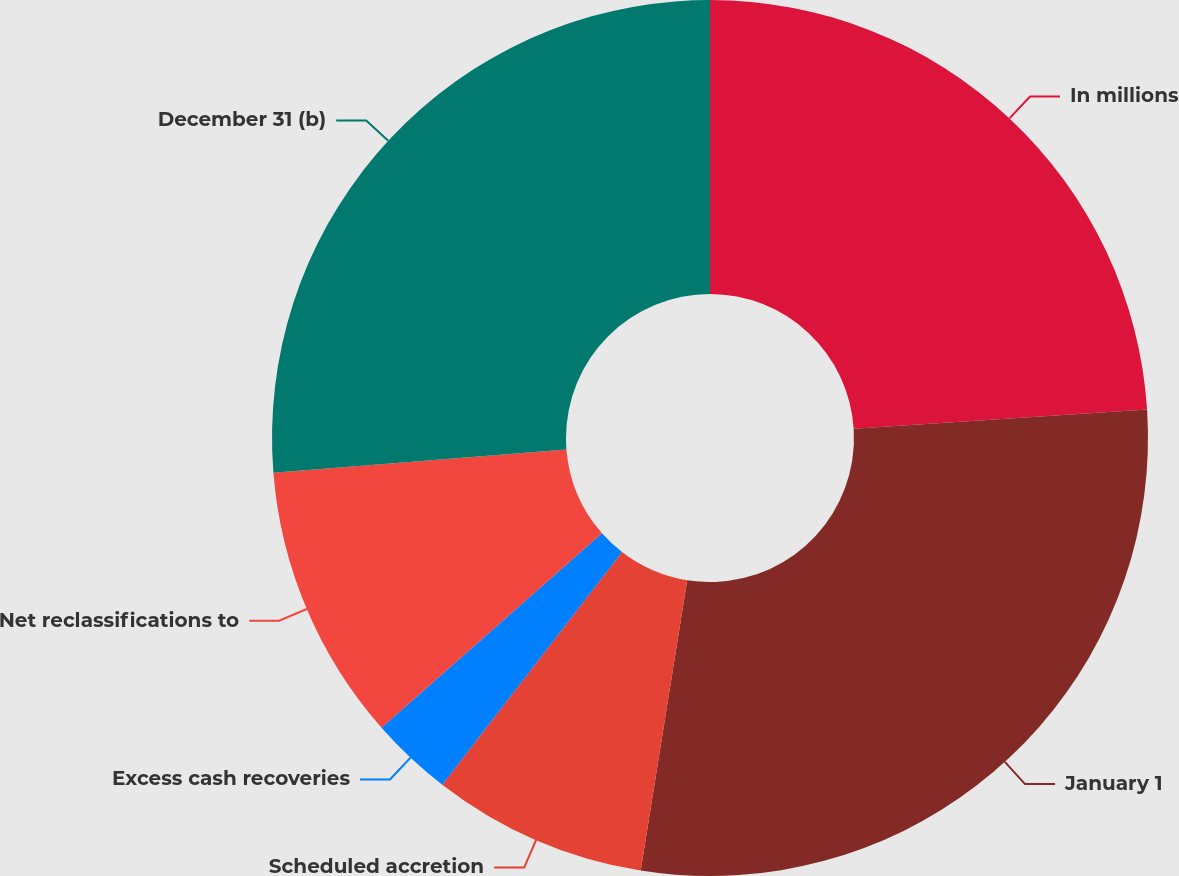Convert chart. <chart><loc_0><loc_0><loc_500><loc_500><pie_chart><fcel>In millions<fcel>January 1<fcel>Scheduled accretion<fcel>Excess cash recoveries<fcel>Net reclassifications to<fcel>December 31 (b)<nl><fcel>23.97%<fcel>28.57%<fcel>7.94%<fcel>3.03%<fcel>10.24%<fcel>26.27%<nl></chart> 